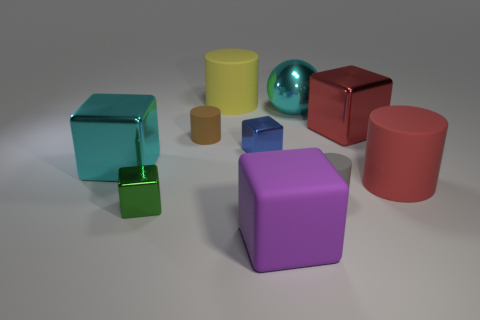The large rubber thing that is on the left side of the red rubber object and behind the tiny gray cylinder is what color?
Keep it short and to the point. Yellow. What is the large object in front of the large red rubber cylinder made of?
Keep it short and to the point. Rubber. Are there any large purple objects that have the same shape as the big yellow matte object?
Keep it short and to the point. No. How many other things are there of the same shape as the small green shiny thing?
Give a very brief answer. 4. Is the shape of the yellow matte object the same as the gray rubber object that is behind the green block?
Provide a short and direct response. Yes. Is there any other thing that has the same material as the small green block?
Make the answer very short. Yes. There is a brown thing that is the same shape as the small gray rubber thing; what is it made of?
Offer a very short reply. Rubber. What number of big objects are either brown metallic cubes or shiny blocks?
Give a very brief answer. 2. Is the number of large yellow cylinders that are behind the yellow cylinder less than the number of small cylinders in front of the big purple cube?
Your answer should be very brief. No. How many things are small purple metal objects or red metal objects?
Keep it short and to the point. 1. 